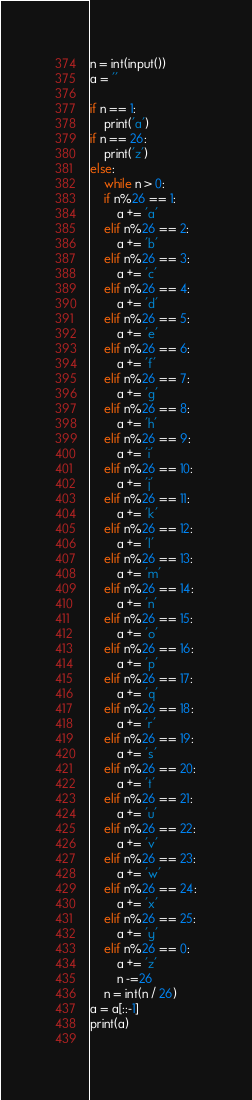Convert code to text. <code><loc_0><loc_0><loc_500><loc_500><_Python_>n = int(input())
a = ''

if n == 1:
    print('a')
if n == 26:
    print('z')
else:
    while n > 0:
    if n%26 == 1:
        a += 'a'
    elif n%26 == 2:
        a += 'b'
    elif n%26 == 3:
        a += 'c'
    elif n%26 == 4:
        a += 'd'
    elif n%26 == 5:
        a += 'e'
    elif n%26 == 6:
        a += 'f'
    elif n%26 == 7:
        a += 'g'
    elif n%26 == 8:
        a += 'h'
    elif n%26 == 9:
        a += 'i'
    elif n%26 == 10:
        a += 'j'
    elif n%26 == 11:
        a += 'k'
    elif n%26 == 12:
        a += 'l'
    elif n%26 == 13:
        a += 'm'
    elif n%26 == 14:
        a += 'n'
    elif n%26 == 15:
        a += 'o'
    elif n%26 == 16:
        a += 'p'
    elif n%26 == 17:
        a += 'q'
    elif n%26 == 18:
        a += 'r'
    elif n%26 == 19:
        a += 's'
    elif n%26 == 20:
        a += 't'
    elif n%26 == 21:
        a += 'u'
    elif n%26 == 22:
        a += 'v'
    elif n%26 == 23:
        a += 'w'
    elif n%26 == 24:
        a += 'x'
    elif n%26 == 25:
        a += 'y'
    elif n%26 == 0:
        a += 'z'
        n -=26
    n = int(n / 26)
a = a[::-1]
print(a)
    

</code> 